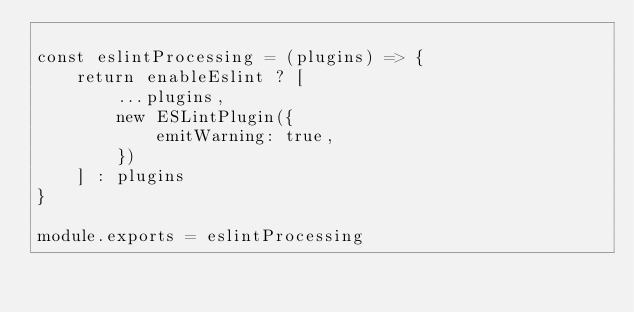<code> <loc_0><loc_0><loc_500><loc_500><_JavaScript_>
const eslintProcessing = (plugins) => {
    return enableEslint ? [
        ...plugins,
        new ESLintPlugin({
            emitWarning: true,
        })
    ] : plugins
}

module.exports = eslintProcessing
</code> 